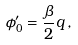<formula> <loc_0><loc_0><loc_500><loc_500>\phi _ { 0 } ^ { \prime } = \frac { \beta } { 2 } q \, ,</formula> 